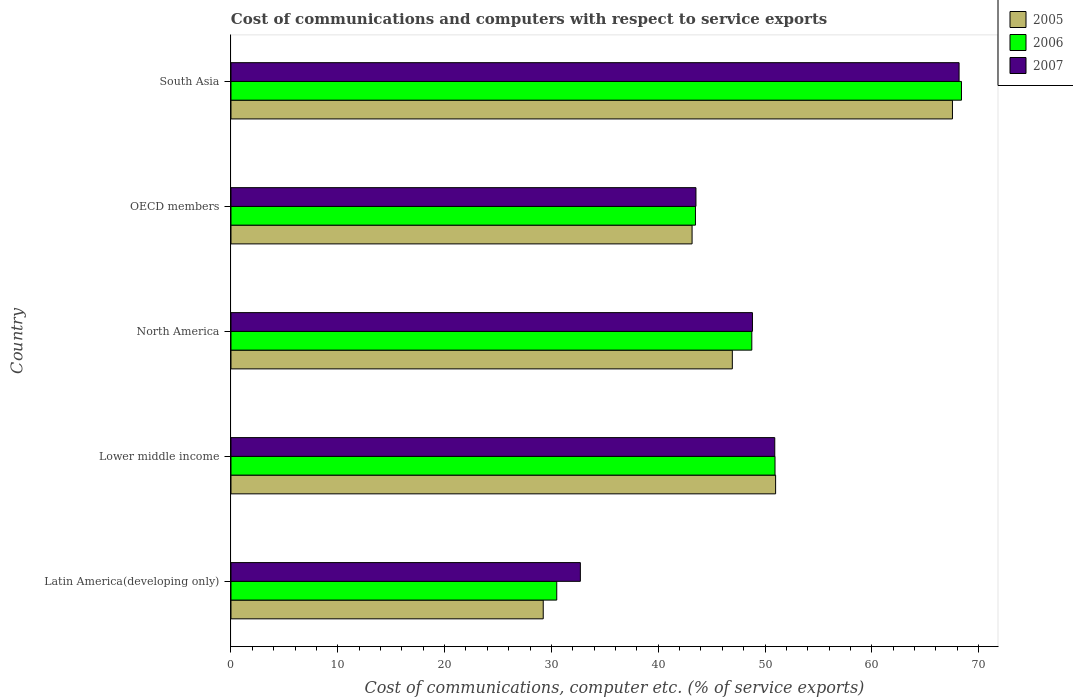How many different coloured bars are there?
Your response must be concise. 3. How many bars are there on the 1st tick from the top?
Offer a very short reply. 3. What is the label of the 2nd group of bars from the top?
Your answer should be very brief. OECD members. What is the cost of communications and computers in 2007 in South Asia?
Your response must be concise. 68.16. Across all countries, what is the maximum cost of communications and computers in 2007?
Your answer should be very brief. 68.16. Across all countries, what is the minimum cost of communications and computers in 2005?
Make the answer very short. 29.23. In which country was the cost of communications and computers in 2005 maximum?
Your answer should be compact. South Asia. In which country was the cost of communications and computers in 2007 minimum?
Offer a very short reply. Latin America(developing only). What is the total cost of communications and computers in 2007 in the graph?
Make the answer very short. 244.12. What is the difference between the cost of communications and computers in 2007 in North America and that in OECD members?
Give a very brief answer. 5.29. What is the difference between the cost of communications and computers in 2006 in Latin America(developing only) and the cost of communications and computers in 2007 in OECD members?
Your response must be concise. -13.03. What is the average cost of communications and computers in 2006 per country?
Make the answer very short. 48.41. What is the difference between the cost of communications and computers in 2007 and cost of communications and computers in 2005 in Latin America(developing only)?
Provide a short and direct response. 3.48. What is the ratio of the cost of communications and computers in 2006 in Lower middle income to that in South Asia?
Give a very brief answer. 0.74. Is the difference between the cost of communications and computers in 2007 in Lower middle income and South Asia greater than the difference between the cost of communications and computers in 2005 in Lower middle income and South Asia?
Provide a short and direct response. No. What is the difference between the highest and the second highest cost of communications and computers in 2005?
Ensure brevity in your answer.  16.55. What is the difference between the highest and the lowest cost of communications and computers in 2006?
Offer a terse response. 37.89. In how many countries, is the cost of communications and computers in 2005 greater than the average cost of communications and computers in 2005 taken over all countries?
Provide a succinct answer. 2. What does the 2nd bar from the top in Latin America(developing only) represents?
Ensure brevity in your answer.  2006. Is it the case that in every country, the sum of the cost of communications and computers in 2007 and cost of communications and computers in 2005 is greater than the cost of communications and computers in 2006?
Make the answer very short. Yes. How many bars are there?
Offer a terse response. 15. What is the difference between two consecutive major ticks on the X-axis?
Give a very brief answer. 10. Does the graph contain any zero values?
Provide a succinct answer. No. Does the graph contain grids?
Provide a succinct answer. No. Where does the legend appear in the graph?
Your answer should be compact. Top right. How many legend labels are there?
Make the answer very short. 3. How are the legend labels stacked?
Offer a terse response. Vertical. What is the title of the graph?
Keep it short and to the point. Cost of communications and computers with respect to service exports. Does "1977" appear as one of the legend labels in the graph?
Provide a short and direct response. No. What is the label or title of the X-axis?
Make the answer very short. Cost of communications, computer etc. (% of service exports). What is the label or title of the Y-axis?
Keep it short and to the point. Country. What is the Cost of communications, computer etc. (% of service exports) of 2005 in Latin America(developing only)?
Give a very brief answer. 29.23. What is the Cost of communications, computer etc. (% of service exports) of 2006 in Latin America(developing only)?
Your response must be concise. 30.5. What is the Cost of communications, computer etc. (% of service exports) of 2007 in Latin America(developing only)?
Your answer should be very brief. 32.71. What is the Cost of communications, computer etc. (% of service exports) of 2005 in Lower middle income?
Give a very brief answer. 50.99. What is the Cost of communications, computer etc. (% of service exports) of 2006 in Lower middle income?
Provide a short and direct response. 50.93. What is the Cost of communications, computer etc. (% of service exports) in 2007 in Lower middle income?
Your answer should be compact. 50.91. What is the Cost of communications, computer etc. (% of service exports) in 2005 in North America?
Provide a short and direct response. 46.93. What is the Cost of communications, computer etc. (% of service exports) of 2006 in North America?
Make the answer very short. 48.76. What is the Cost of communications, computer etc. (% of service exports) of 2007 in North America?
Provide a succinct answer. 48.82. What is the Cost of communications, computer etc. (% of service exports) of 2005 in OECD members?
Provide a succinct answer. 43.17. What is the Cost of communications, computer etc. (% of service exports) in 2006 in OECD members?
Offer a very short reply. 43.48. What is the Cost of communications, computer etc. (% of service exports) of 2007 in OECD members?
Offer a very short reply. 43.53. What is the Cost of communications, computer etc. (% of service exports) in 2005 in South Asia?
Offer a terse response. 67.54. What is the Cost of communications, computer etc. (% of service exports) of 2006 in South Asia?
Provide a succinct answer. 68.39. What is the Cost of communications, computer etc. (% of service exports) in 2007 in South Asia?
Provide a succinct answer. 68.16. Across all countries, what is the maximum Cost of communications, computer etc. (% of service exports) in 2005?
Give a very brief answer. 67.54. Across all countries, what is the maximum Cost of communications, computer etc. (% of service exports) in 2006?
Provide a short and direct response. 68.39. Across all countries, what is the maximum Cost of communications, computer etc. (% of service exports) in 2007?
Your response must be concise. 68.16. Across all countries, what is the minimum Cost of communications, computer etc. (% of service exports) in 2005?
Your response must be concise. 29.23. Across all countries, what is the minimum Cost of communications, computer etc. (% of service exports) in 2006?
Offer a terse response. 30.5. Across all countries, what is the minimum Cost of communications, computer etc. (% of service exports) in 2007?
Give a very brief answer. 32.71. What is the total Cost of communications, computer etc. (% of service exports) in 2005 in the graph?
Offer a very short reply. 237.86. What is the total Cost of communications, computer etc. (% of service exports) in 2006 in the graph?
Offer a very short reply. 242.05. What is the total Cost of communications, computer etc. (% of service exports) of 2007 in the graph?
Give a very brief answer. 244.12. What is the difference between the Cost of communications, computer etc. (% of service exports) of 2005 in Latin America(developing only) and that in Lower middle income?
Your answer should be very brief. -21.75. What is the difference between the Cost of communications, computer etc. (% of service exports) in 2006 in Latin America(developing only) and that in Lower middle income?
Offer a very short reply. -20.43. What is the difference between the Cost of communications, computer etc. (% of service exports) of 2007 in Latin America(developing only) and that in Lower middle income?
Ensure brevity in your answer.  -18.2. What is the difference between the Cost of communications, computer etc. (% of service exports) in 2005 in Latin America(developing only) and that in North America?
Your answer should be compact. -17.7. What is the difference between the Cost of communications, computer etc. (% of service exports) of 2006 in Latin America(developing only) and that in North America?
Your answer should be very brief. -18.26. What is the difference between the Cost of communications, computer etc. (% of service exports) in 2007 in Latin America(developing only) and that in North America?
Ensure brevity in your answer.  -16.11. What is the difference between the Cost of communications, computer etc. (% of service exports) in 2005 in Latin America(developing only) and that in OECD members?
Make the answer very short. -13.93. What is the difference between the Cost of communications, computer etc. (% of service exports) of 2006 in Latin America(developing only) and that in OECD members?
Offer a terse response. -12.98. What is the difference between the Cost of communications, computer etc. (% of service exports) of 2007 in Latin America(developing only) and that in OECD members?
Keep it short and to the point. -10.82. What is the difference between the Cost of communications, computer etc. (% of service exports) in 2005 in Latin America(developing only) and that in South Asia?
Provide a short and direct response. -38.31. What is the difference between the Cost of communications, computer etc. (% of service exports) of 2006 in Latin America(developing only) and that in South Asia?
Your answer should be compact. -37.89. What is the difference between the Cost of communications, computer etc. (% of service exports) of 2007 in Latin America(developing only) and that in South Asia?
Offer a very short reply. -35.45. What is the difference between the Cost of communications, computer etc. (% of service exports) of 2005 in Lower middle income and that in North America?
Offer a terse response. 4.05. What is the difference between the Cost of communications, computer etc. (% of service exports) in 2006 in Lower middle income and that in North America?
Your answer should be compact. 2.17. What is the difference between the Cost of communications, computer etc. (% of service exports) of 2007 in Lower middle income and that in North America?
Your answer should be very brief. 2.09. What is the difference between the Cost of communications, computer etc. (% of service exports) of 2005 in Lower middle income and that in OECD members?
Offer a very short reply. 7.82. What is the difference between the Cost of communications, computer etc. (% of service exports) in 2006 in Lower middle income and that in OECD members?
Give a very brief answer. 7.45. What is the difference between the Cost of communications, computer etc. (% of service exports) of 2007 in Lower middle income and that in OECD members?
Provide a succinct answer. 7.38. What is the difference between the Cost of communications, computer etc. (% of service exports) in 2005 in Lower middle income and that in South Asia?
Ensure brevity in your answer.  -16.55. What is the difference between the Cost of communications, computer etc. (% of service exports) of 2006 in Lower middle income and that in South Asia?
Provide a succinct answer. -17.45. What is the difference between the Cost of communications, computer etc. (% of service exports) in 2007 in Lower middle income and that in South Asia?
Give a very brief answer. -17.25. What is the difference between the Cost of communications, computer etc. (% of service exports) of 2005 in North America and that in OECD members?
Provide a succinct answer. 3.77. What is the difference between the Cost of communications, computer etc. (% of service exports) of 2006 in North America and that in OECD members?
Provide a short and direct response. 5.28. What is the difference between the Cost of communications, computer etc. (% of service exports) in 2007 in North America and that in OECD members?
Your response must be concise. 5.29. What is the difference between the Cost of communications, computer etc. (% of service exports) of 2005 in North America and that in South Asia?
Your answer should be compact. -20.61. What is the difference between the Cost of communications, computer etc. (% of service exports) of 2006 in North America and that in South Asia?
Your response must be concise. -19.63. What is the difference between the Cost of communications, computer etc. (% of service exports) of 2007 in North America and that in South Asia?
Offer a very short reply. -19.34. What is the difference between the Cost of communications, computer etc. (% of service exports) of 2005 in OECD members and that in South Asia?
Ensure brevity in your answer.  -24.37. What is the difference between the Cost of communications, computer etc. (% of service exports) of 2006 in OECD members and that in South Asia?
Provide a short and direct response. -24.9. What is the difference between the Cost of communications, computer etc. (% of service exports) in 2007 in OECD members and that in South Asia?
Your answer should be very brief. -24.63. What is the difference between the Cost of communications, computer etc. (% of service exports) of 2005 in Latin America(developing only) and the Cost of communications, computer etc. (% of service exports) of 2006 in Lower middle income?
Your response must be concise. -21.7. What is the difference between the Cost of communications, computer etc. (% of service exports) of 2005 in Latin America(developing only) and the Cost of communications, computer etc. (% of service exports) of 2007 in Lower middle income?
Your answer should be compact. -21.67. What is the difference between the Cost of communications, computer etc. (% of service exports) in 2006 in Latin America(developing only) and the Cost of communications, computer etc. (% of service exports) in 2007 in Lower middle income?
Provide a short and direct response. -20.41. What is the difference between the Cost of communications, computer etc. (% of service exports) in 2005 in Latin America(developing only) and the Cost of communications, computer etc. (% of service exports) in 2006 in North America?
Your answer should be compact. -19.53. What is the difference between the Cost of communications, computer etc. (% of service exports) of 2005 in Latin America(developing only) and the Cost of communications, computer etc. (% of service exports) of 2007 in North America?
Keep it short and to the point. -19.59. What is the difference between the Cost of communications, computer etc. (% of service exports) in 2006 in Latin America(developing only) and the Cost of communications, computer etc. (% of service exports) in 2007 in North America?
Make the answer very short. -18.32. What is the difference between the Cost of communications, computer etc. (% of service exports) in 2005 in Latin America(developing only) and the Cost of communications, computer etc. (% of service exports) in 2006 in OECD members?
Make the answer very short. -14.25. What is the difference between the Cost of communications, computer etc. (% of service exports) of 2005 in Latin America(developing only) and the Cost of communications, computer etc. (% of service exports) of 2007 in OECD members?
Your answer should be compact. -14.3. What is the difference between the Cost of communications, computer etc. (% of service exports) of 2006 in Latin America(developing only) and the Cost of communications, computer etc. (% of service exports) of 2007 in OECD members?
Ensure brevity in your answer.  -13.03. What is the difference between the Cost of communications, computer etc. (% of service exports) in 2005 in Latin America(developing only) and the Cost of communications, computer etc. (% of service exports) in 2006 in South Asia?
Keep it short and to the point. -39.15. What is the difference between the Cost of communications, computer etc. (% of service exports) in 2005 in Latin America(developing only) and the Cost of communications, computer etc. (% of service exports) in 2007 in South Asia?
Your response must be concise. -38.93. What is the difference between the Cost of communications, computer etc. (% of service exports) of 2006 in Latin America(developing only) and the Cost of communications, computer etc. (% of service exports) of 2007 in South Asia?
Offer a terse response. -37.66. What is the difference between the Cost of communications, computer etc. (% of service exports) in 2005 in Lower middle income and the Cost of communications, computer etc. (% of service exports) in 2006 in North America?
Your response must be concise. 2.23. What is the difference between the Cost of communications, computer etc. (% of service exports) in 2005 in Lower middle income and the Cost of communications, computer etc. (% of service exports) in 2007 in North America?
Make the answer very short. 2.17. What is the difference between the Cost of communications, computer etc. (% of service exports) of 2006 in Lower middle income and the Cost of communications, computer etc. (% of service exports) of 2007 in North America?
Keep it short and to the point. 2.11. What is the difference between the Cost of communications, computer etc. (% of service exports) of 2005 in Lower middle income and the Cost of communications, computer etc. (% of service exports) of 2006 in OECD members?
Your response must be concise. 7.5. What is the difference between the Cost of communications, computer etc. (% of service exports) of 2005 in Lower middle income and the Cost of communications, computer etc. (% of service exports) of 2007 in OECD members?
Offer a terse response. 7.46. What is the difference between the Cost of communications, computer etc. (% of service exports) of 2006 in Lower middle income and the Cost of communications, computer etc. (% of service exports) of 2007 in OECD members?
Provide a short and direct response. 7.4. What is the difference between the Cost of communications, computer etc. (% of service exports) in 2005 in Lower middle income and the Cost of communications, computer etc. (% of service exports) in 2006 in South Asia?
Provide a short and direct response. -17.4. What is the difference between the Cost of communications, computer etc. (% of service exports) of 2005 in Lower middle income and the Cost of communications, computer etc. (% of service exports) of 2007 in South Asia?
Ensure brevity in your answer.  -17.18. What is the difference between the Cost of communications, computer etc. (% of service exports) in 2006 in Lower middle income and the Cost of communications, computer etc. (% of service exports) in 2007 in South Asia?
Your answer should be compact. -17.23. What is the difference between the Cost of communications, computer etc. (% of service exports) of 2005 in North America and the Cost of communications, computer etc. (% of service exports) of 2006 in OECD members?
Provide a succinct answer. 3.45. What is the difference between the Cost of communications, computer etc. (% of service exports) of 2005 in North America and the Cost of communications, computer etc. (% of service exports) of 2007 in OECD members?
Make the answer very short. 3.41. What is the difference between the Cost of communications, computer etc. (% of service exports) in 2006 in North America and the Cost of communications, computer etc. (% of service exports) in 2007 in OECD members?
Your answer should be compact. 5.23. What is the difference between the Cost of communications, computer etc. (% of service exports) of 2005 in North America and the Cost of communications, computer etc. (% of service exports) of 2006 in South Asia?
Offer a terse response. -21.45. What is the difference between the Cost of communications, computer etc. (% of service exports) in 2005 in North America and the Cost of communications, computer etc. (% of service exports) in 2007 in South Asia?
Your answer should be compact. -21.23. What is the difference between the Cost of communications, computer etc. (% of service exports) of 2006 in North America and the Cost of communications, computer etc. (% of service exports) of 2007 in South Asia?
Keep it short and to the point. -19.4. What is the difference between the Cost of communications, computer etc. (% of service exports) in 2005 in OECD members and the Cost of communications, computer etc. (% of service exports) in 2006 in South Asia?
Offer a very short reply. -25.22. What is the difference between the Cost of communications, computer etc. (% of service exports) in 2005 in OECD members and the Cost of communications, computer etc. (% of service exports) in 2007 in South Asia?
Make the answer very short. -24.99. What is the difference between the Cost of communications, computer etc. (% of service exports) of 2006 in OECD members and the Cost of communications, computer etc. (% of service exports) of 2007 in South Asia?
Offer a very short reply. -24.68. What is the average Cost of communications, computer etc. (% of service exports) of 2005 per country?
Provide a short and direct response. 47.57. What is the average Cost of communications, computer etc. (% of service exports) of 2006 per country?
Keep it short and to the point. 48.41. What is the average Cost of communications, computer etc. (% of service exports) in 2007 per country?
Provide a succinct answer. 48.82. What is the difference between the Cost of communications, computer etc. (% of service exports) in 2005 and Cost of communications, computer etc. (% of service exports) in 2006 in Latin America(developing only)?
Offer a terse response. -1.26. What is the difference between the Cost of communications, computer etc. (% of service exports) of 2005 and Cost of communications, computer etc. (% of service exports) of 2007 in Latin America(developing only)?
Ensure brevity in your answer.  -3.48. What is the difference between the Cost of communications, computer etc. (% of service exports) of 2006 and Cost of communications, computer etc. (% of service exports) of 2007 in Latin America(developing only)?
Ensure brevity in your answer.  -2.21. What is the difference between the Cost of communications, computer etc. (% of service exports) in 2005 and Cost of communications, computer etc. (% of service exports) in 2006 in Lower middle income?
Keep it short and to the point. 0.06. What is the difference between the Cost of communications, computer etc. (% of service exports) of 2005 and Cost of communications, computer etc. (% of service exports) of 2007 in Lower middle income?
Give a very brief answer. 0.08. What is the difference between the Cost of communications, computer etc. (% of service exports) in 2006 and Cost of communications, computer etc. (% of service exports) in 2007 in Lower middle income?
Make the answer very short. 0.02. What is the difference between the Cost of communications, computer etc. (% of service exports) of 2005 and Cost of communications, computer etc. (% of service exports) of 2006 in North America?
Offer a very short reply. -1.82. What is the difference between the Cost of communications, computer etc. (% of service exports) in 2005 and Cost of communications, computer etc. (% of service exports) in 2007 in North America?
Keep it short and to the point. -1.88. What is the difference between the Cost of communications, computer etc. (% of service exports) in 2006 and Cost of communications, computer etc. (% of service exports) in 2007 in North America?
Provide a short and direct response. -0.06. What is the difference between the Cost of communications, computer etc. (% of service exports) of 2005 and Cost of communications, computer etc. (% of service exports) of 2006 in OECD members?
Give a very brief answer. -0.32. What is the difference between the Cost of communications, computer etc. (% of service exports) of 2005 and Cost of communications, computer etc. (% of service exports) of 2007 in OECD members?
Provide a succinct answer. -0.36. What is the difference between the Cost of communications, computer etc. (% of service exports) in 2006 and Cost of communications, computer etc. (% of service exports) in 2007 in OECD members?
Offer a very short reply. -0.05. What is the difference between the Cost of communications, computer etc. (% of service exports) of 2005 and Cost of communications, computer etc. (% of service exports) of 2006 in South Asia?
Give a very brief answer. -0.84. What is the difference between the Cost of communications, computer etc. (% of service exports) of 2005 and Cost of communications, computer etc. (% of service exports) of 2007 in South Asia?
Keep it short and to the point. -0.62. What is the difference between the Cost of communications, computer etc. (% of service exports) of 2006 and Cost of communications, computer etc. (% of service exports) of 2007 in South Asia?
Give a very brief answer. 0.22. What is the ratio of the Cost of communications, computer etc. (% of service exports) of 2005 in Latin America(developing only) to that in Lower middle income?
Your answer should be very brief. 0.57. What is the ratio of the Cost of communications, computer etc. (% of service exports) in 2006 in Latin America(developing only) to that in Lower middle income?
Your response must be concise. 0.6. What is the ratio of the Cost of communications, computer etc. (% of service exports) in 2007 in Latin America(developing only) to that in Lower middle income?
Give a very brief answer. 0.64. What is the ratio of the Cost of communications, computer etc. (% of service exports) in 2005 in Latin America(developing only) to that in North America?
Give a very brief answer. 0.62. What is the ratio of the Cost of communications, computer etc. (% of service exports) of 2006 in Latin America(developing only) to that in North America?
Ensure brevity in your answer.  0.63. What is the ratio of the Cost of communications, computer etc. (% of service exports) in 2007 in Latin America(developing only) to that in North America?
Your answer should be very brief. 0.67. What is the ratio of the Cost of communications, computer etc. (% of service exports) of 2005 in Latin America(developing only) to that in OECD members?
Keep it short and to the point. 0.68. What is the ratio of the Cost of communications, computer etc. (% of service exports) of 2006 in Latin America(developing only) to that in OECD members?
Offer a terse response. 0.7. What is the ratio of the Cost of communications, computer etc. (% of service exports) in 2007 in Latin America(developing only) to that in OECD members?
Your response must be concise. 0.75. What is the ratio of the Cost of communications, computer etc. (% of service exports) of 2005 in Latin America(developing only) to that in South Asia?
Provide a short and direct response. 0.43. What is the ratio of the Cost of communications, computer etc. (% of service exports) of 2006 in Latin America(developing only) to that in South Asia?
Give a very brief answer. 0.45. What is the ratio of the Cost of communications, computer etc. (% of service exports) in 2007 in Latin America(developing only) to that in South Asia?
Your response must be concise. 0.48. What is the ratio of the Cost of communications, computer etc. (% of service exports) of 2005 in Lower middle income to that in North America?
Provide a succinct answer. 1.09. What is the ratio of the Cost of communications, computer etc. (% of service exports) in 2006 in Lower middle income to that in North America?
Keep it short and to the point. 1.04. What is the ratio of the Cost of communications, computer etc. (% of service exports) in 2007 in Lower middle income to that in North America?
Provide a succinct answer. 1.04. What is the ratio of the Cost of communications, computer etc. (% of service exports) of 2005 in Lower middle income to that in OECD members?
Give a very brief answer. 1.18. What is the ratio of the Cost of communications, computer etc. (% of service exports) of 2006 in Lower middle income to that in OECD members?
Ensure brevity in your answer.  1.17. What is the ratio of the Cost of communications, computer etc. (% of service exports) of 2007 in Lower middle income to that in OECD members?
Your response must be concise. 1.17. What is the ratio of the Cost of communications, computer etc. (% of service exports) of 2005 in Lower middle income to that in South Asia?
Your response must be concise. 0.75. What is the ratio of the Cost of communications, computer etc. (% of service exports) in 2006 in Lower middle income to that in South Asia?
Provide a short and direct response. 0.74. What is the ratio of the Cost of communications, computer etc. (% of service exports) of 2007 in Lower middle income to that in South Asia?
Your answer should be very brief. 0.75. What is the ratio of the Cost of communications, computer etc. (% of service exports) in 2005 in North America to that in OECD members?
Your answer should be very brief. 1.09. What is the ratio of the Cost of communications, computer etc. (% of service exports) of 2006 in North America to that in OECD members?
Offer a terse response. 1.12. What is the ratio of the Cost of communications, computer etc. (% of service exports) of 2007 in North America to that in OECD members?
Your response must be concise. 1.12. What is the ratio of the Cost of communications, computer etc. (% of service exports) in 2005 in North America to that in South Asia?
Offer a very short reply. 0.69. What is the ratio of the Cost of communications, computer etc. (% of service exports) of 2006 in North America to that in South Asia?
Provide a succinct answer. 0.71. What is the ratio of the Cost of communications, computer etc. (% of service exports) in 2007 in North America to that in South Asia?
Ensure brevity in your answer.  0.72. What is the ratio of the Cost of communications, computer etc. (% of service exports) in 2005 in OECD members to that in South Asia?
Your answer should be very brief. 0.64. What is the ratio of the Cost of communications, computer etc. (% of service exports) of 2006 in OECD members to that in South Asia?
Offer a very short reply. 0.64. What is the ratio of the Cost of communications, computer etc. (% of service exports) of 2007 in OECD members to that in South Asia?
Keep it short and to the point. 0.64. What is the difference between the highest and the second highest Cost of communications, computer etc. (% of service exports) in 2005?
Make the answer very short. 16.55. What is the difference between the highest and the second highest Cost of communications, computer etc. (% of service exports) of 2006?
Your response must be concise. 17.45. What is the difference between the highest and the second highest Cost of communications, computer etc. (% of service exports) in 2007?
Give a very brief answer. 17.25. What is the difference between the highest and the lowest Cost of communications, computer etc. (% of service exports) in 2005?
Make the answer very short. 38.31. What is the difference between the highest and the lowest Cost of communications, computer etc. (% of service exports) of 2006?
Provide a succinct answer. 37.89. What is the difference between the highest and the lowest Cost of communications, computer etc. (% of service exports) of 2007?
Offer a very short reply. 35.45. 